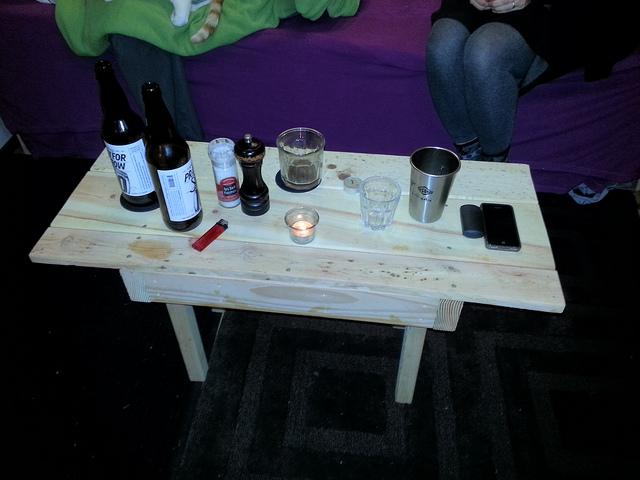Is there a smartphone on the table?
Short answer required. Yes. What is this item?
Concise answer only. Table. What is on the tabletop?
Keep it brief. Drinks. What color are the candles?
Write a very short answer. White. What is inside the vase?
Be succinct. Candle. Is the candle lit?
Concise answer only. Yes. What is the table made out of?
Write a very short answer. Wood. What two events are being celebrated?
Keep it brief. Birthday, anniversary. 